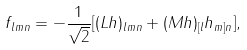<formula> <loc_0><loc_0><loc_500><loc_500>f _ { l m n } = - \frac { 1 } { \sqrt { 2 } } [ ( L h ) _ { l m n } + ( M h ) _ { [ l } h _ { m ] n } ] ,</formula> 